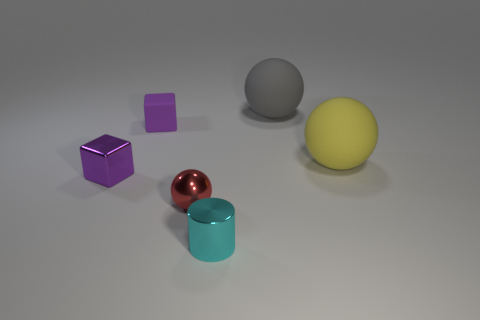Add 4 tiny red cubes. How many objects exist? 10 Subtract all cubes. How many objects are left? 4 Add 5 yellow rubber things. How many yellow rubber things exist? 6 Subtract 0 purple spheres. How many objects are left? 6 Subtract all big green metal balls. Subtract all gray matte objects. How many objects are left? 5 Add 3 red objects. How many red objects are left? 4 